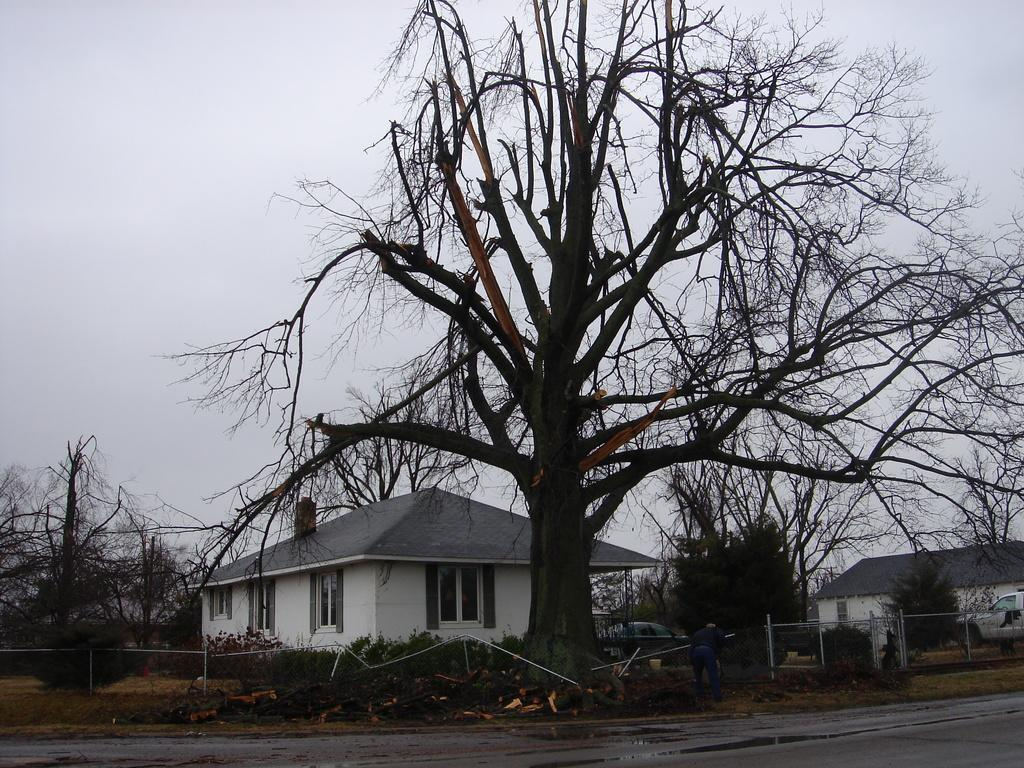What type of structures can be seen in the image? There are buildings in the image. What other natural elements are present in the image? There are trees in the image. Can you describe the person in the image? There is a person standing and holding an object in the image. What type of transportation can be seen in the image? There are vehicles in the image. What is visible at the top of the image? The sky is visible at the top of the image. What surface is at the bottom of the image? There is a road at the bottom of the image. What type of sheet is being used to cover the bike in the image? There is no bike or sheet present in the image. How is the ice being transported in the image? There is no ice present in the image. 